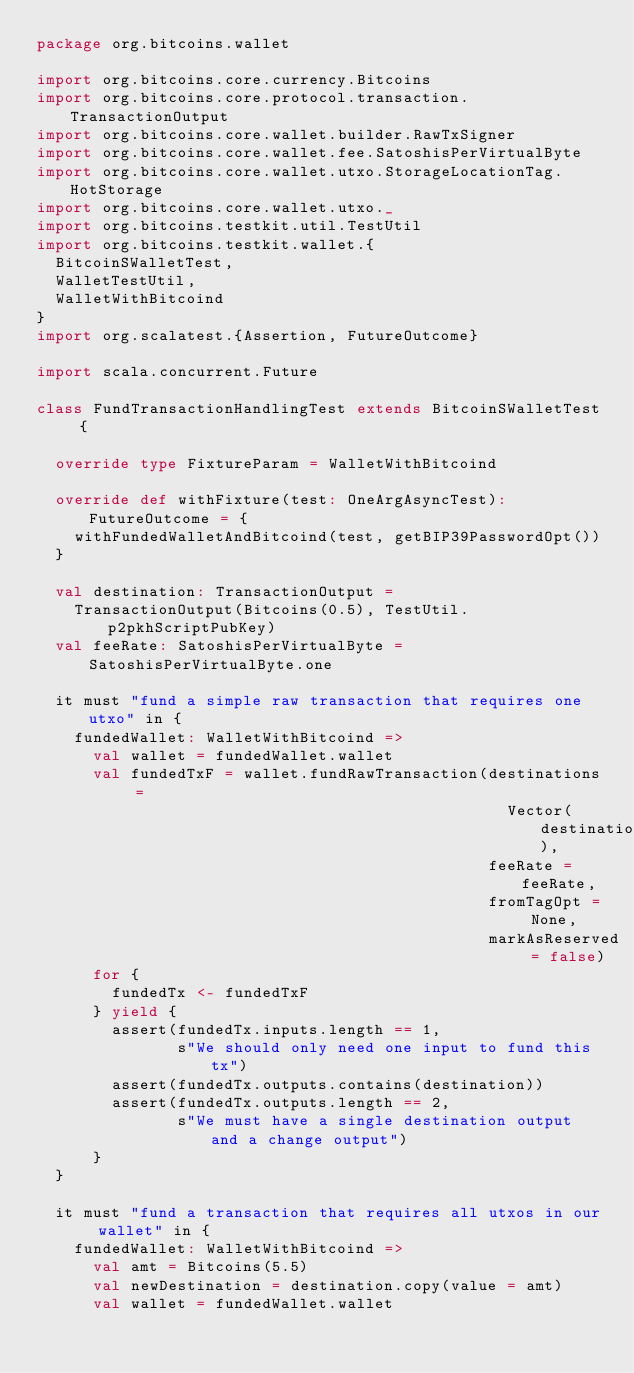<code> <loc_0><loc_0><loc_500><loc_500><_Scala_>package org.bitcoins.wallet

import org.bitcoins.core.currency.Bitcoins
import org.bitcoins.core.protocol.transaction.TransactionOutput
import org.bitcoins.core.wallet.builder.RawTxSigner
import org.bitcoins.core.wallet.fee.SatoshisPerVirtualByte
import org.bitcoins.core.wallet.utxo.StorageLocationTag.HotStorage
import org.bitcoins.core.wallet.utxo._
import org.bitcoins.testkit.util.TestUtil
import org.bitcoins.testkit.wallet.{
  BitcoinSWalletTest,
  WalletTestUtil,
  WalletWithBitcoind
}
import org.scalatest.{Assertion, FutureOutcome}

import scala.concurrent.Future

class FundTransactionHandlingTest extends BitcoinSWalletTest {

  override type FixtureParam = WalletWithBitcoind

  override def withFixture(test: OneArgAsyncTest): FutureOutcome = {
    withFundedWalletAndBitcoind(test, getBIP39PasswordOpt())
  }

  val destination: TransactionOutput =
    TransactionOutput(Bitcoins(0.5), TestUtil.p2pkhScriptPubKey)
  val feeRate: SatoshisPerVirtualByte = SatoshisPerVirtualByte.one

  it must "fund a simple raw transaction that requires one utxo" in {
    fundedWallet: WalletWithBitcoind =>
      val wallet = fundedWallet.wallet
      val fundedTxF = wallet.fundRawTransaction(destinations =
                                                  Vector(destination),
                                                feeRate = feeRate,
                                                fromTagOpt = None,
                                                markAsReserved = false)
      for {
        fundedTx <- fundedTxF
      } yield {
        assert(fundedTx.inputs.length == 1,
               s"We should only need one input to fund this tx")
        assert(fundedTx.outputs.contains(destination))
        assert(fundedTx.outputs.length == 2,
               s"We must have a single destination output and a change output")
      }
  }

  it must "fund a transaction that requires all utxos in our wallet" in {
    fundedWallet: WalletWithBitcoind =>
      val amt = Bitcoins(5.5)
      val newDestination = destination.copy(value = amt)
      val wallet = fundedWallet.wallet</code> 